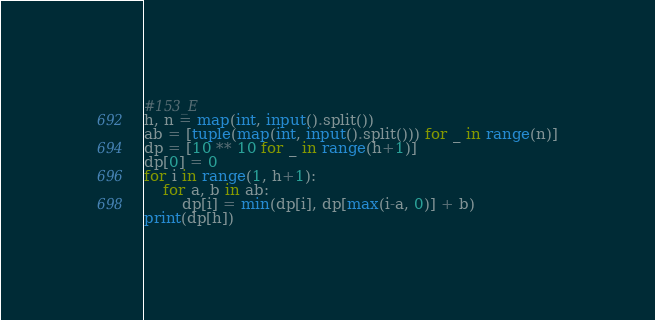Convert code to text. <code><loc_0><loc_0><loc_500><loc_500><_Python_>#153_E
h, n = map(int, input().split())
ab = [tuple(map(int, input().split())) for _ in range(n)]
dp = [10 ** 10 for _ in range(h+1)]
dp[0] = 0
for i in range(1, h+1):
    for a, b in ab:
        dp[i] = min(dp[i], dp[max(i-a, 0)] + b)
print(dp[h])</code> 